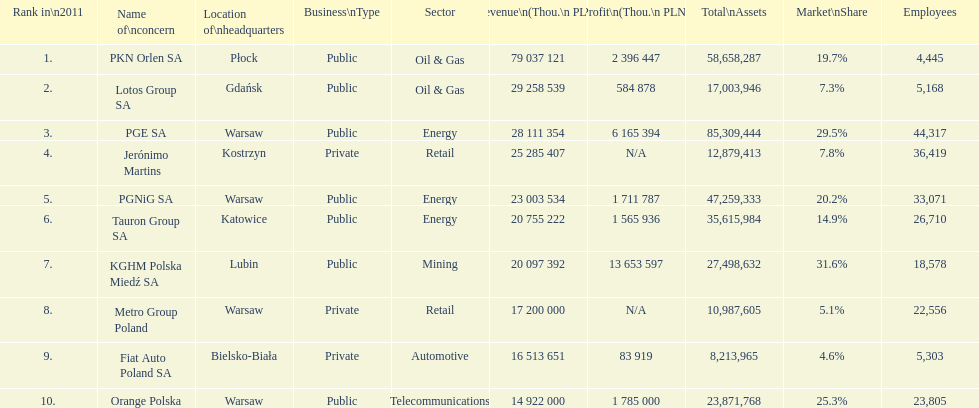How many companies had over $1,000,000 profit? 6. 